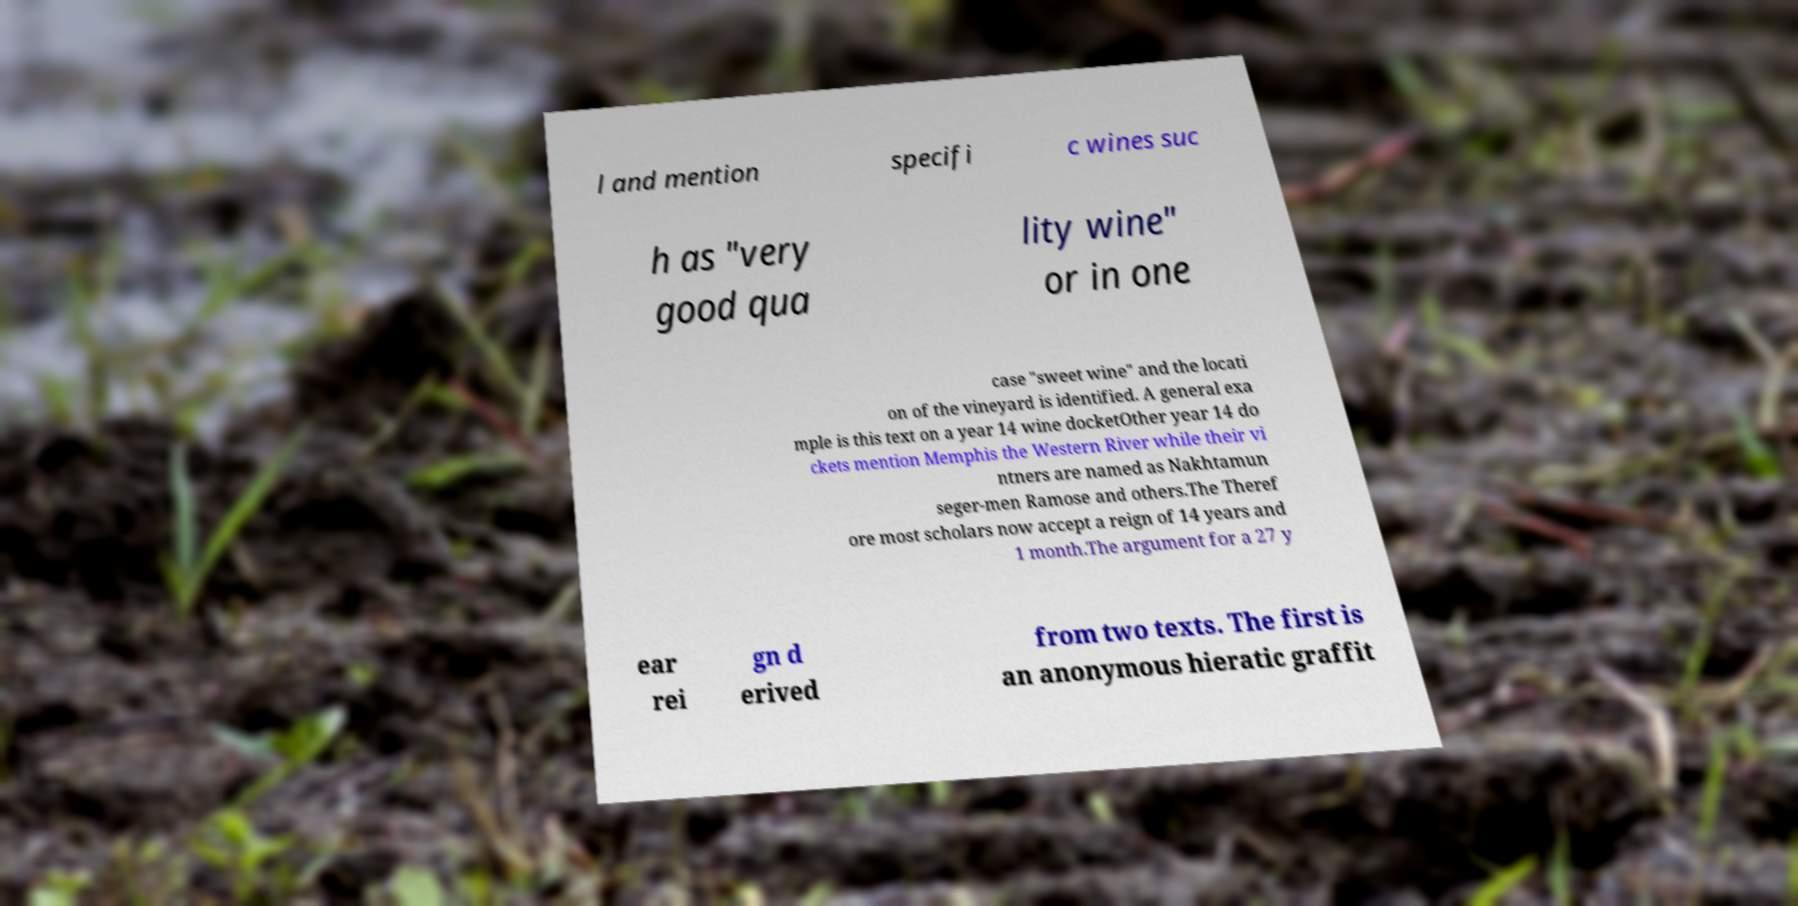Please identify and transcribe the text found in this image. l and mention specifi c wines suc h as "very good qua lity wine" or in one case "sweet wine" and the locati on of the vineyard is identified. A general exa mple is this text on a year 14 wine docketOther year 14 do ckets mention Memphis the Western River while their vi ntners are named as Nakhtamun seger-men Ramose and others.The Theref ore most scholars now accept a reign of 14 years and 1 month.The argument for a 27 y ear rei gn d erived from two texts. The first is an anonymous hieratic graffit 